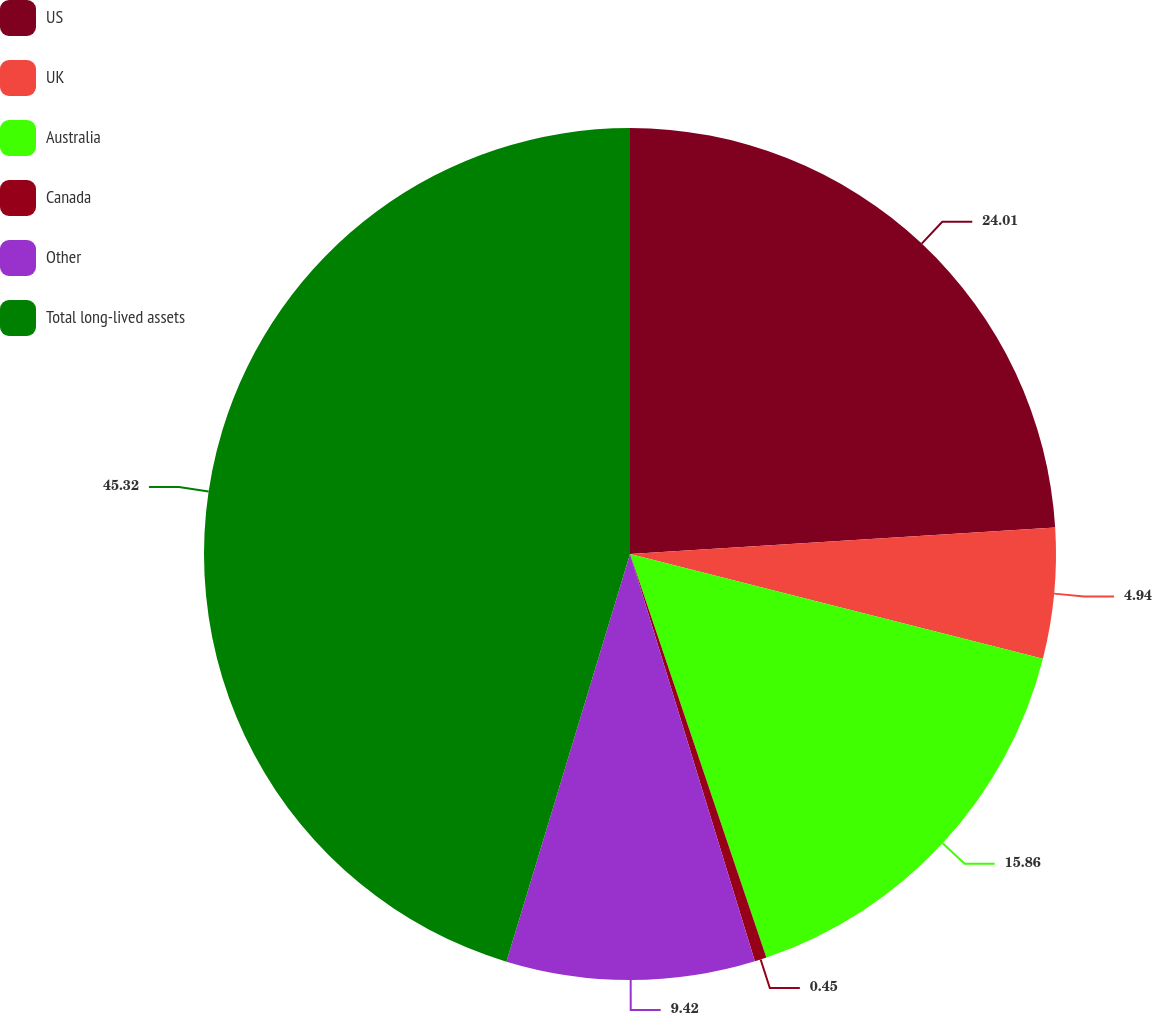Convert chart to OTSL. <chart><loc_0><loc_0><loc_500><loc_500><pie_chart><fcel>US<fcel>UK<fcel>Australia<fcel>Canada<fcel>Other<fcel>Total long-lived assets<nl><fcel>24.01%<fcel>4.94%<fcel>15.86%<fcel>0.45%<fcel>9.42%<fcel>45.31%<nl></chart> 